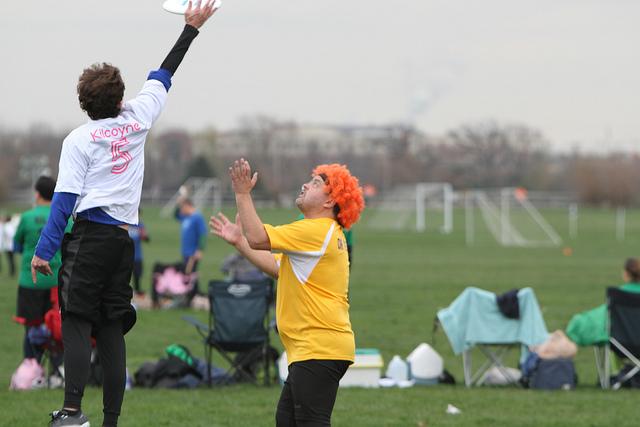Is this sport in the Summer Olympics?
Keep it brief. No. Did the guy with a yellow shirt get the frisbee?
Keep it brief. No. What sport can be played on the field?
Be succinct. Soccer. 